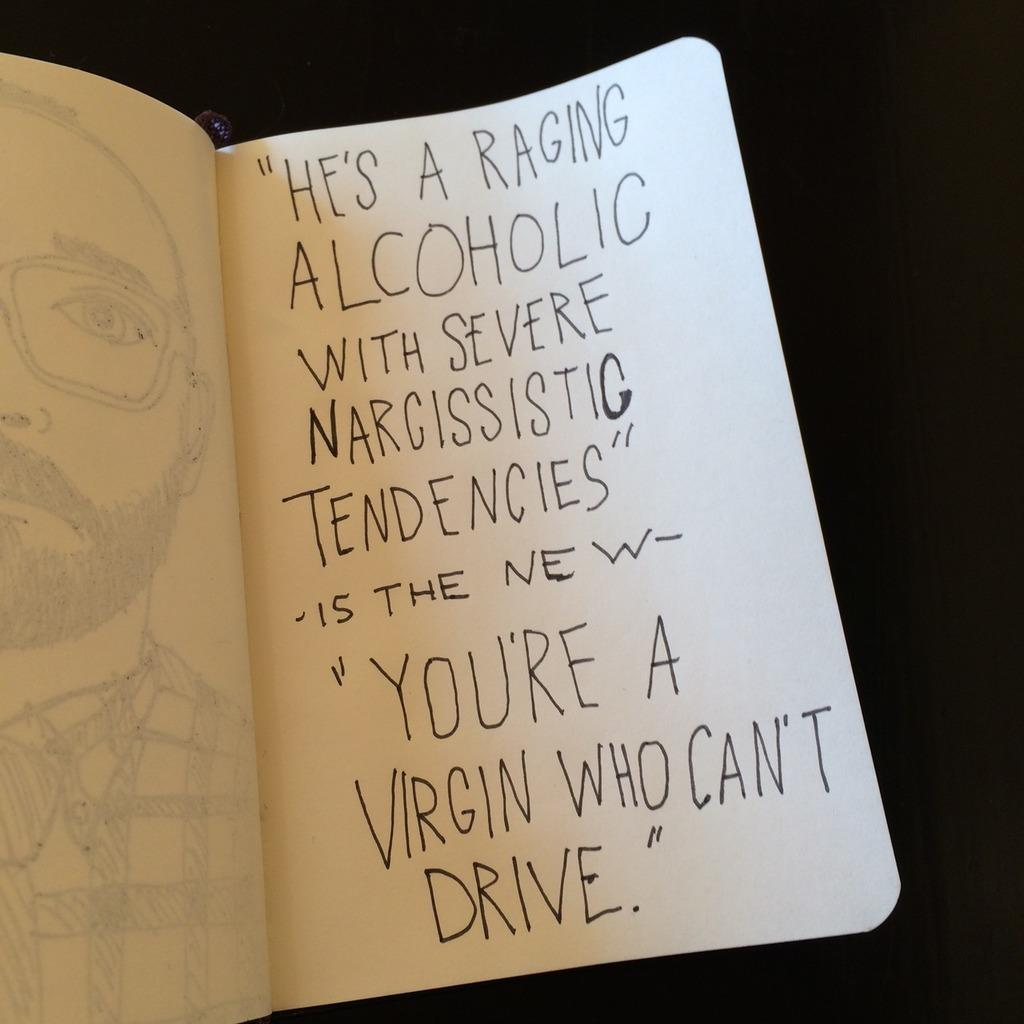<image>
Offer a succinct explanation of the picture presented. A sketch of a man has text beginning with the words he's a raging alcoholic. 